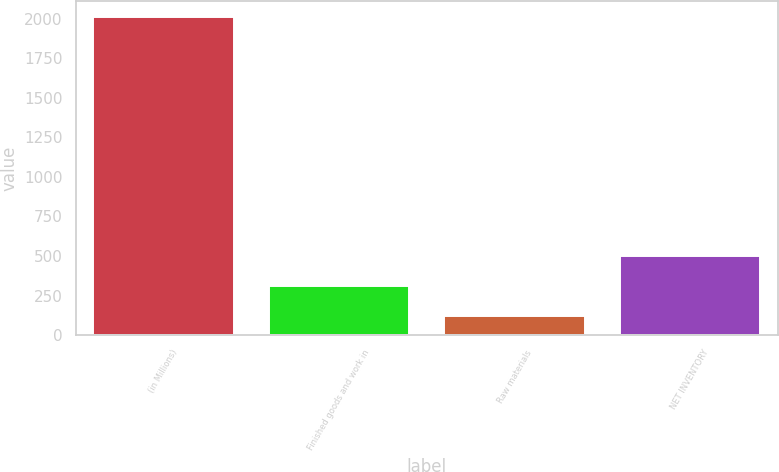Convert chart to OTSL. <chart><loc_0><loc_0><loc_500><loc_500><bar_chart><fcel>(in Millions)<fcel>Finished goods and work in<fcel>Raw materials<fcel>NET INVENTORY<nl><fcel>2010<fcel>310.98<fcel>122.2<fcel>499.76<nl></chart> 